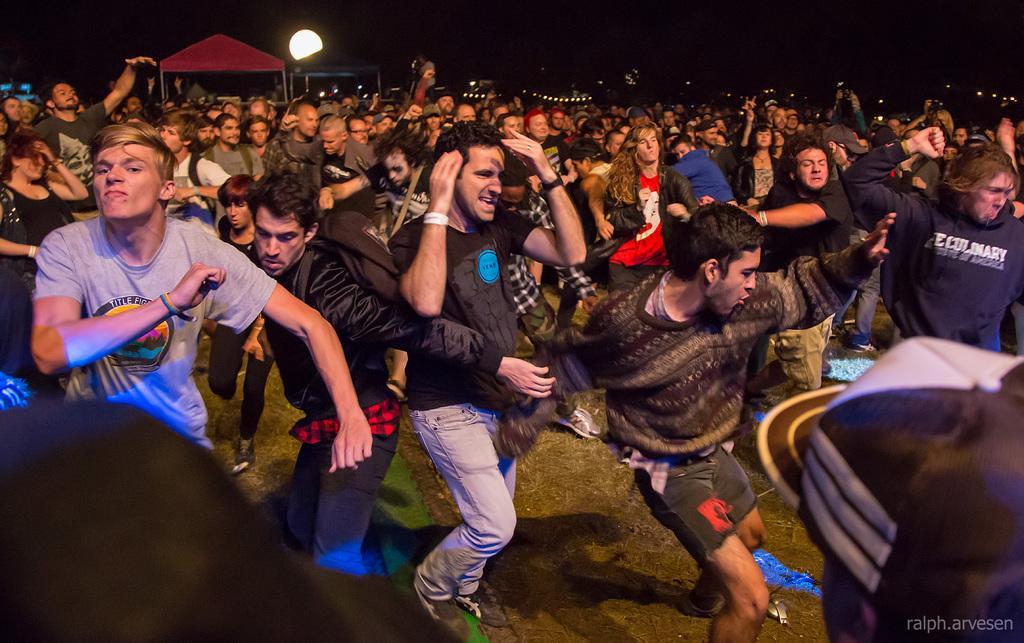In one or two sentences, can you explain what this image depicts? In this image we can see some group of persons dancing in the open area and in the background of the image there are some huts and lights. 